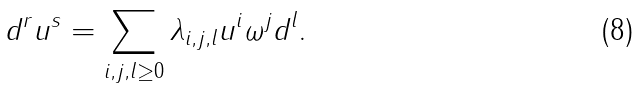Convert formula to latex. <formula><loc_0><loc_0><loc_500><loc_500>d ^ { r } u ^ { s } = \sum _ { i , j , l \geq 0 } \lambda _ { i , j , l } u ^ { i } \omega ^ { j } d ^ { l } .</formula> 